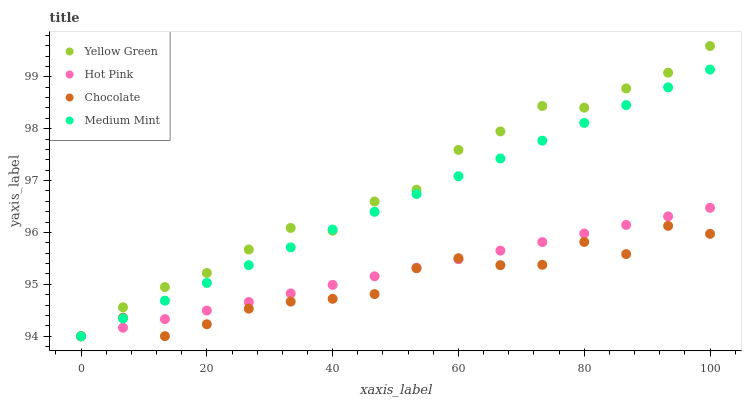Does Chocolate have the minimum area under the curve?
Answer yes or no. Yes. Does Yellow Green have the maximum area under the curve?
Answer yes or no. Yes. Does Hot Pink have the minimum area under the curve?
Answer yes or no. No. Does Hot Pink have the maximum area under the curve?
Answer yes or no. No. Is Medium Mint the smoothest?
Answer yes or no. Yes. Is Chocolate the roughest?
Answer yes or no. Yes. Is Hot Pink the smoothest?
Answer yes or no. No. Is Hot Pink the roughest?
Answer yes or no. No. Does Medium Mint have the lowest value?
Answer yes or no. Yes. Does Yellow Green have the highest value?
Answer yes or no. Yes. Does Hot Pink have the highest value?
Answer yes or no. No. Does Hot Pink intersect Chocolate?
Answer yes or no. Yes. Is Hot Pink less than Chocolate?
Answer yes or no. No. Is Hot Pink greater than Chocolate?
Answer yes or no. No. 